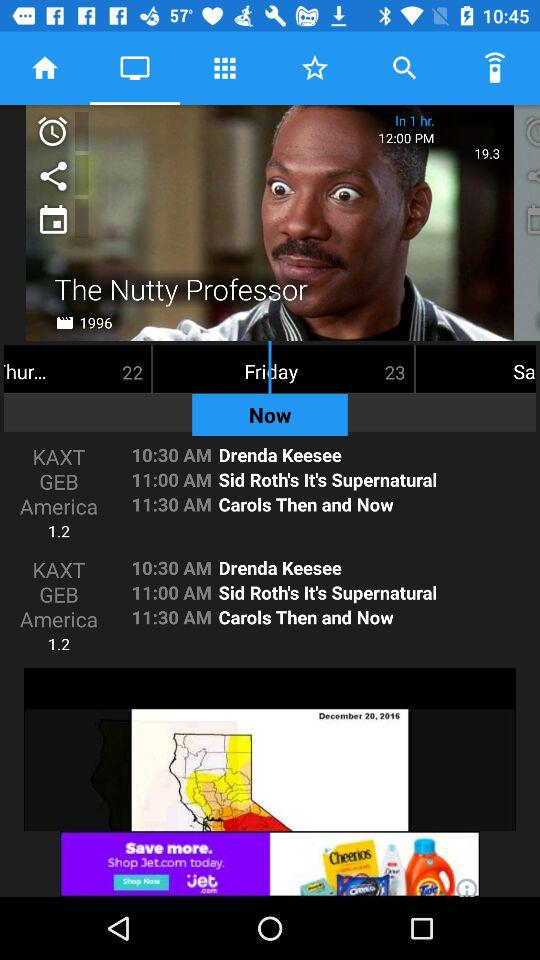What's the telecast time of "Drenda Keesee"? The telecast time of "Drenda Keesee" is 10:30 AM. 